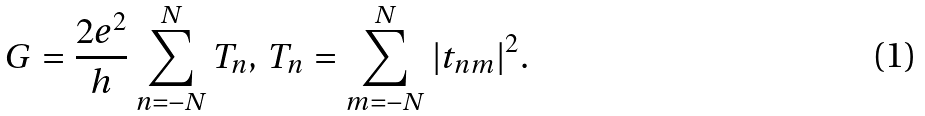Convert formula to latex. <formula><loc_0><loc_0><loc_500><loc_500>G = \frac { 2 e ^ { 2 } } { h } \sum _ { n = - N } ^ { N } T _ { n } , \, T _ { n } = \sum _ { m = - N } ^ { N } | t _ { n m } | ^ { 2 } .</formula> 